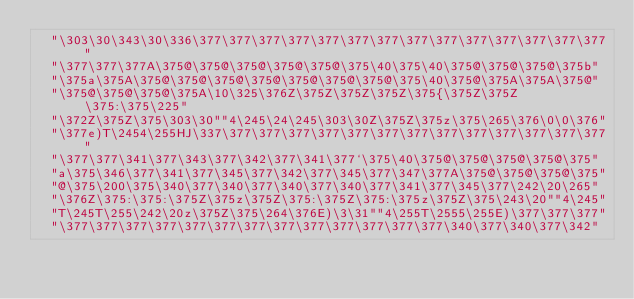<code> <loc_0><loc_0><loc_500><loc_500><_C_>  "\303\30\343\30\336\377\377\377\377\377\377\377\377\377\377\377\377\377\377"
  "\377\377\377A\375@\375@\375@\375@\375@\375\40\375\40\375@\375@\375@\375b"
  "\375a\375A\375@\375@\375@\375@\375@\375@\375@\375\40\375@\375A\375A\375@"
  "\375@\375@\375@\375A\10\325\376Z\375Z\375Z\375Z\375{\375Z\375Z\375:\375\225"
  "\372Z\375Z\375\303\30""4\245\24\245\303\30Z\375Z\375z\375\265\376\0\0\376"
  "\377e)T\2454\255HJ\337\377\377\377\377\377\377\377\377\377\377\377\377\377"
  "\377\377\341\377\343\377\342\377\341\377`\375\40\375@\375@\375@\375@\375"
  "a\375\346\377\341\377\345\377\342\377\345\377\347\377A\375@\375@\375@\375"
  "@\375\200\375\340\377\340\377\340\377\340\377\341\377\345\377\242\20\265"
  "\376Z\375:\375:\375Z\375z\375Z\375:\375Z\375:\375z\375Z\375\243\20""4\245"
  "T\245T\255\242\20z\375Z\375\264\376E)\3\31""4\255T\2555\255E)\377\377\377"
  "\377\377\377\377\377\377\377\377\377\377\377\377\377\340\377\340\377\342"</code> 